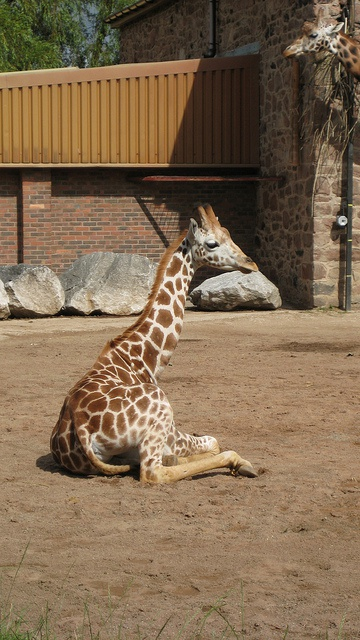Describe the objects in this image and their specific colors. I can see giraffe in darkgreen, gray, tan, black, and maroon tones and giraffe in darkgreen, gray, black, and maroon tones in this image. 